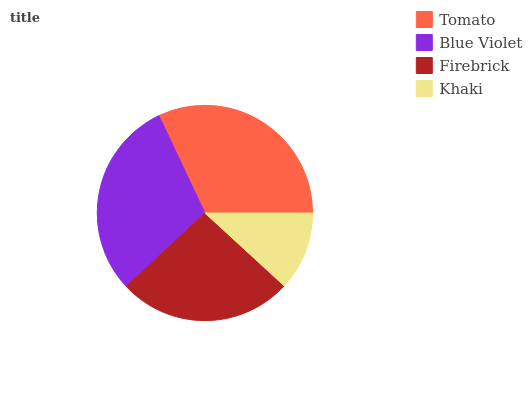Is Khaki the minimum?
Answer yes or no. Yes. Is Tomato the maximum?
Answer yes or no. Yes. Is Blue Violet the minimum?
Answer yes or no. No. Is Blue Violet the maximum?
Answer yes or no. No. Is Tomato greater than Blue Violet?
Answer yes or no. Yes. Is Blue Violet less than Tomato?
Answer yes or no. Yes. Is Blue Violet greater than Tomato?
Answer yes or no. No. Is Tomato less than Blue Violet?
Answer yes or no. No. Is Blue Violet the high median?
Answer yes or no. Yes. Is Firebrick the low median?
Answer yes or no. Yes. Is Tomato the high median?
Answer yes or no. No. Is Tomato the low median?
Answer yes or no. No. 